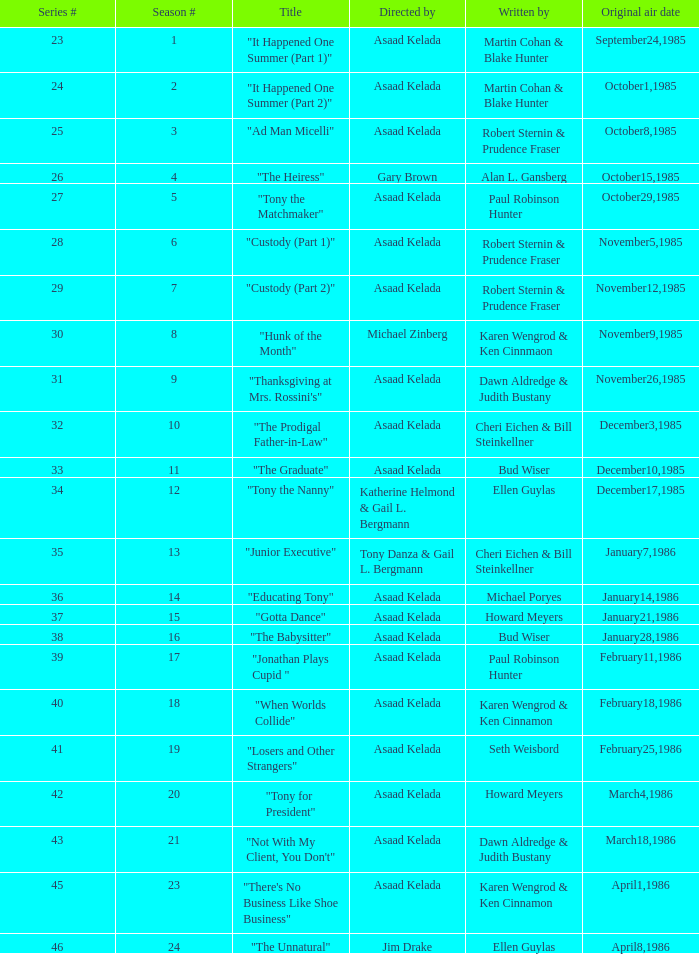What is the season where the episode "when worlds collide" was shown? 18.0. 